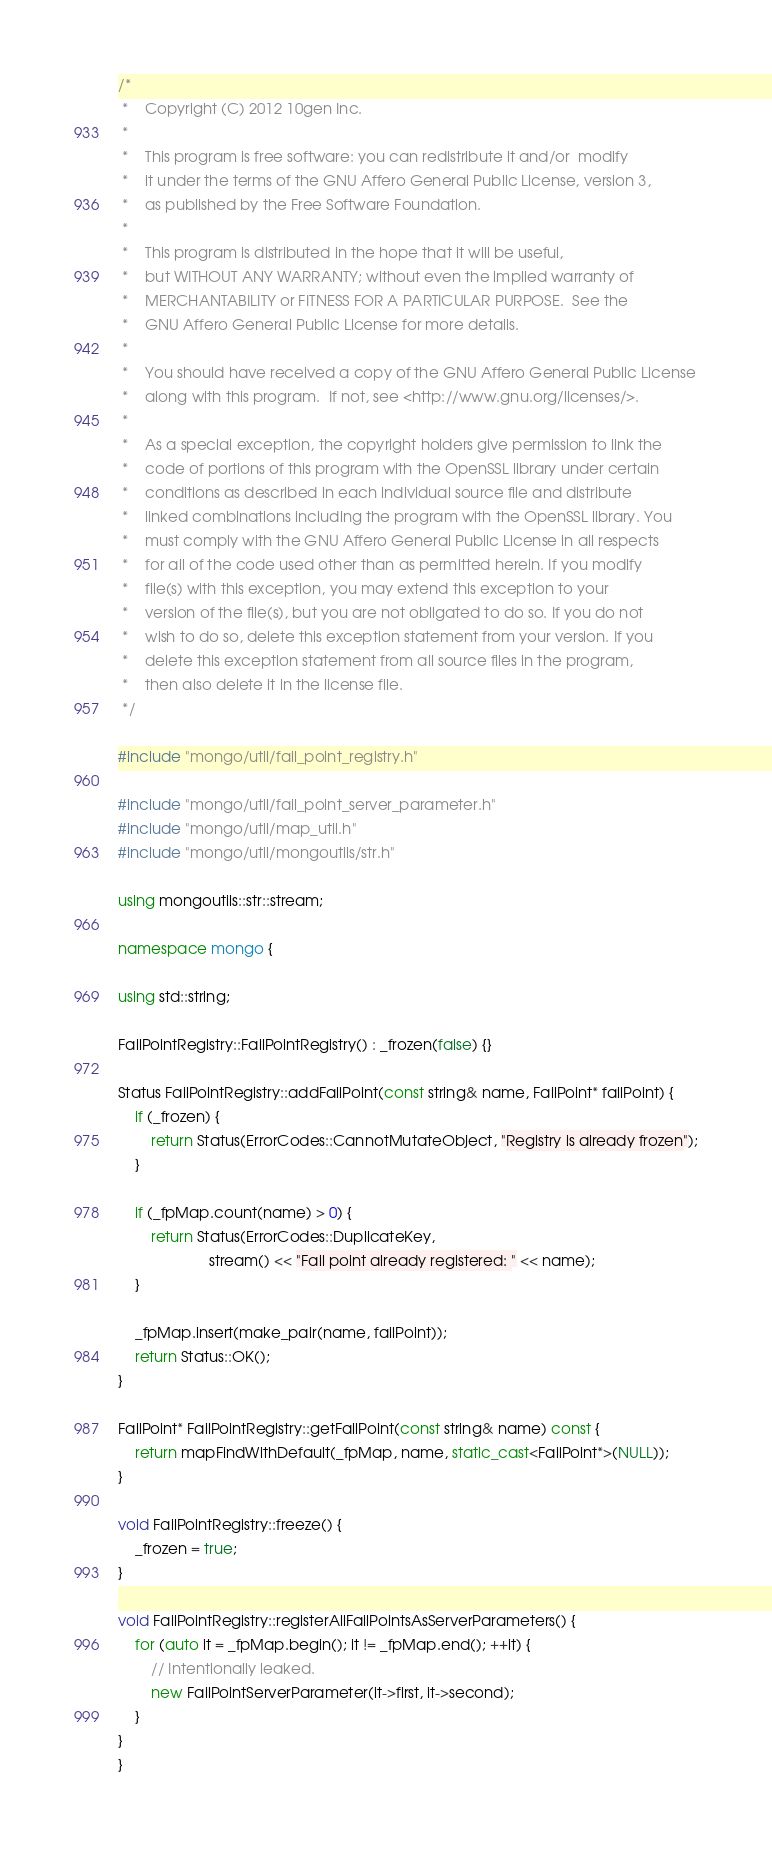<code> <loc_0><loc_0><loc_500><loc_500><_C++_>/*
 *    Copyright (C) 2012 10gen Inc.
 *
 *    This program is free software: you can redistribute it and/or  modify
 *    it under the terms of the GNU Affero General Public License, version 3,
 *    as published by the Free Software Foundation.
 *
 *    This program is distributed in the hope that it will be useful,
 *    but WITHOUT ANY WARRANTY; without even the implied warranty of
 *    MERCHANTABILITY or FITNESS FOR A PARTICULAR PURPOSE.  See the
 *    GNU Affero General Public License for more details.
 *
 *    You should have received a copy of the GNU Affero General Public License
 *    along with this program.  If not, see <http://www.gnu.org/licenses/>.
 *
 *    As a special exception, the copyright holders give permission to link the
 *    code of portions of this program with the OpenSSL library under certain
 *    conditions as described in each individual source file and distribute
 *    linked combinations including the program with the OpenSSL library. You
 *    must comply with the GNU Affero General Public License in all respects
 *    for all of the code used other than as permitted herein. If you modify
 *    file(s) with this exception, you may extend this exception to your
 *    version of the file(s), but you are not obligated to do so. If you do not
 *    wish to do so, delete this exception statement from your version. If you
 *    delete this exception statement from all source files in the program,
 *    then also delete it in the license file.
 */

#include "mongo/util/fail_point_registry.h"

#include "mongo/util/fail_point_server_parameter.h"
#include "mongo/util/map_util.h"
#include "mongo/util/mongoutils/str.h"

using mongoutils::str::stream;

namespace mongo {

using std::string;

FailPointRegistry::FailPointRegistry() : _frozen(false) {}

Status FailPointRegistry::addFailPoint(const string& name, FailPoint* failPoint) {
    if (_frozen) {
        return Status(ErrorCodes::CannotMutateObject, "Registry is already frozen");
    }

    if (_fpMap.count(name) > 0) {
        return Status(ErrorCodes::DuplicateKey,
                      stream() << "Fail point already registered: " << name);
    }

    _fpMap.insert(make_pair(name, failPoint));
    return Status::OK();
}

FailPoint* FailPointRegistry::getFailPoint(const string& name) const {
    return mapFindWithDefault(_fpMap, name, static_cast<FailPoint*>(NULL));
}

void FailPointRegistry::freeze() {
    _frozen = true;
}

void FailPointRegistry::registerAllFailPointsAsServerParameters() {
    for (auto it = _fpMap.begin(); it != _fpMap.end(); ++it) {
        // Intentionally leaked.
        new FailPointServerParameter(it->first, it->second);
    }
}
}
</code> 